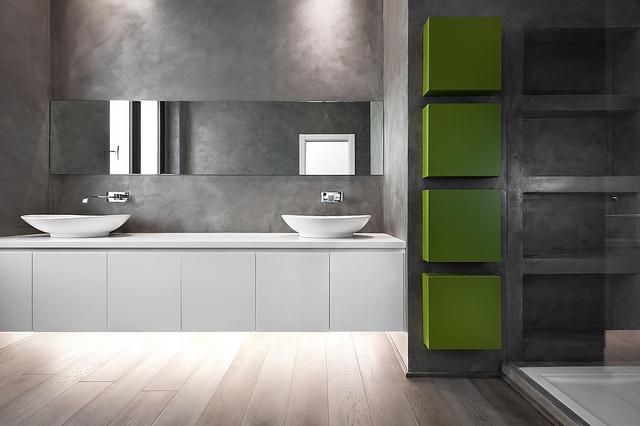Do you like the his and her sink?
Concise answer only. Yes. Does the sink have recessed lighting?
Short answer required. Yes. What room is this?
Keep it brief. Bathroom. 